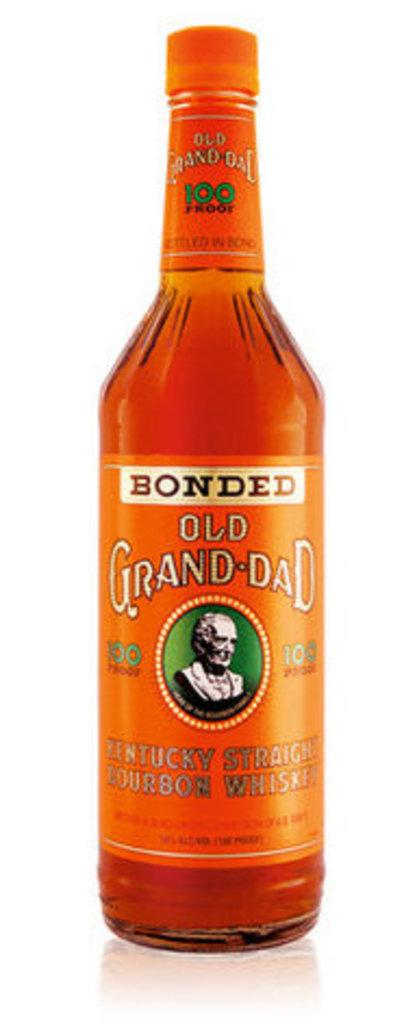<image>
Describe the image concisely. A small orange bottle of Kentuck straight bourbon whiskey 